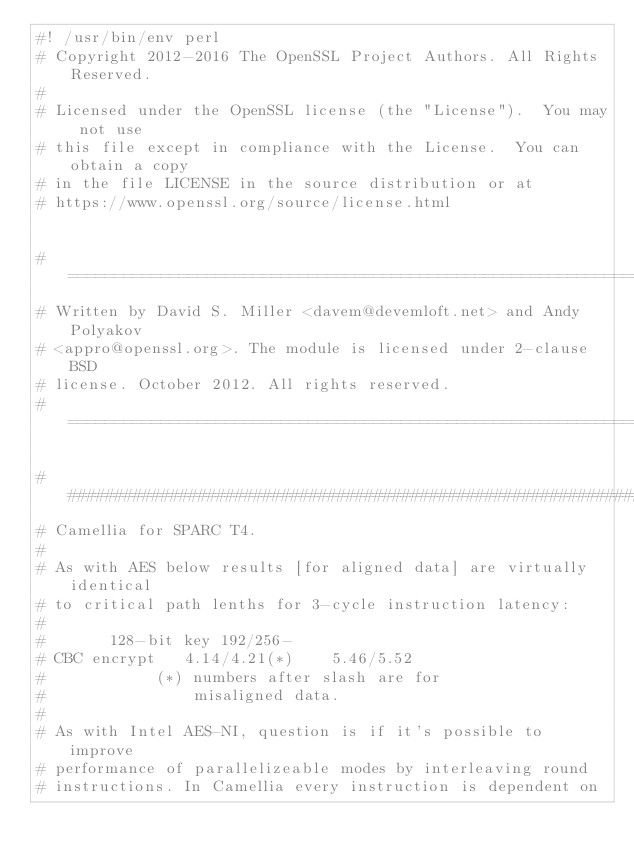Convert code to text. <code><loc_0><loc_0><loc_500><loc_500><_Perl_>#! /usr/bin/env perl
# Copyright 2012-2016 The OpenSSL Project Authors. All Rights Reserved.
#
# Licensed under the OpenSSL license (the "License").  You may not use
# this file except in compliance with the License.  You can obtain a copy
# in the file LICENSE in the source distribution or at
# https://www.openssl.org/source/license.html


# ====================================================================
# Written by David S. Miller <davem@devemloft.net> and Andy Polyakov
# <appro@openssl.org>. The module is licensed under 2-clause BSD
# license. October 2012. All rights reserved.
# ====================================================================

######################################################################
# Camellia for SPARC T4.
#
# As with AES below results [for aligned data] are virtually identical
# to critical path lenths for 3-cycle instruction latency:
#
#		128-bit key	192/256-
# CBC encrypt	4.14/4.21(*)	5.46/5.52
#			 (*) numbers after slash are for
#			     misaligned data.
#
# As with Intel AES-NI, question is if it's possible to improve
# performance of parallelizeable modes by interleaving round
# instructions. In Camellia every instruction is dependent on</code> 